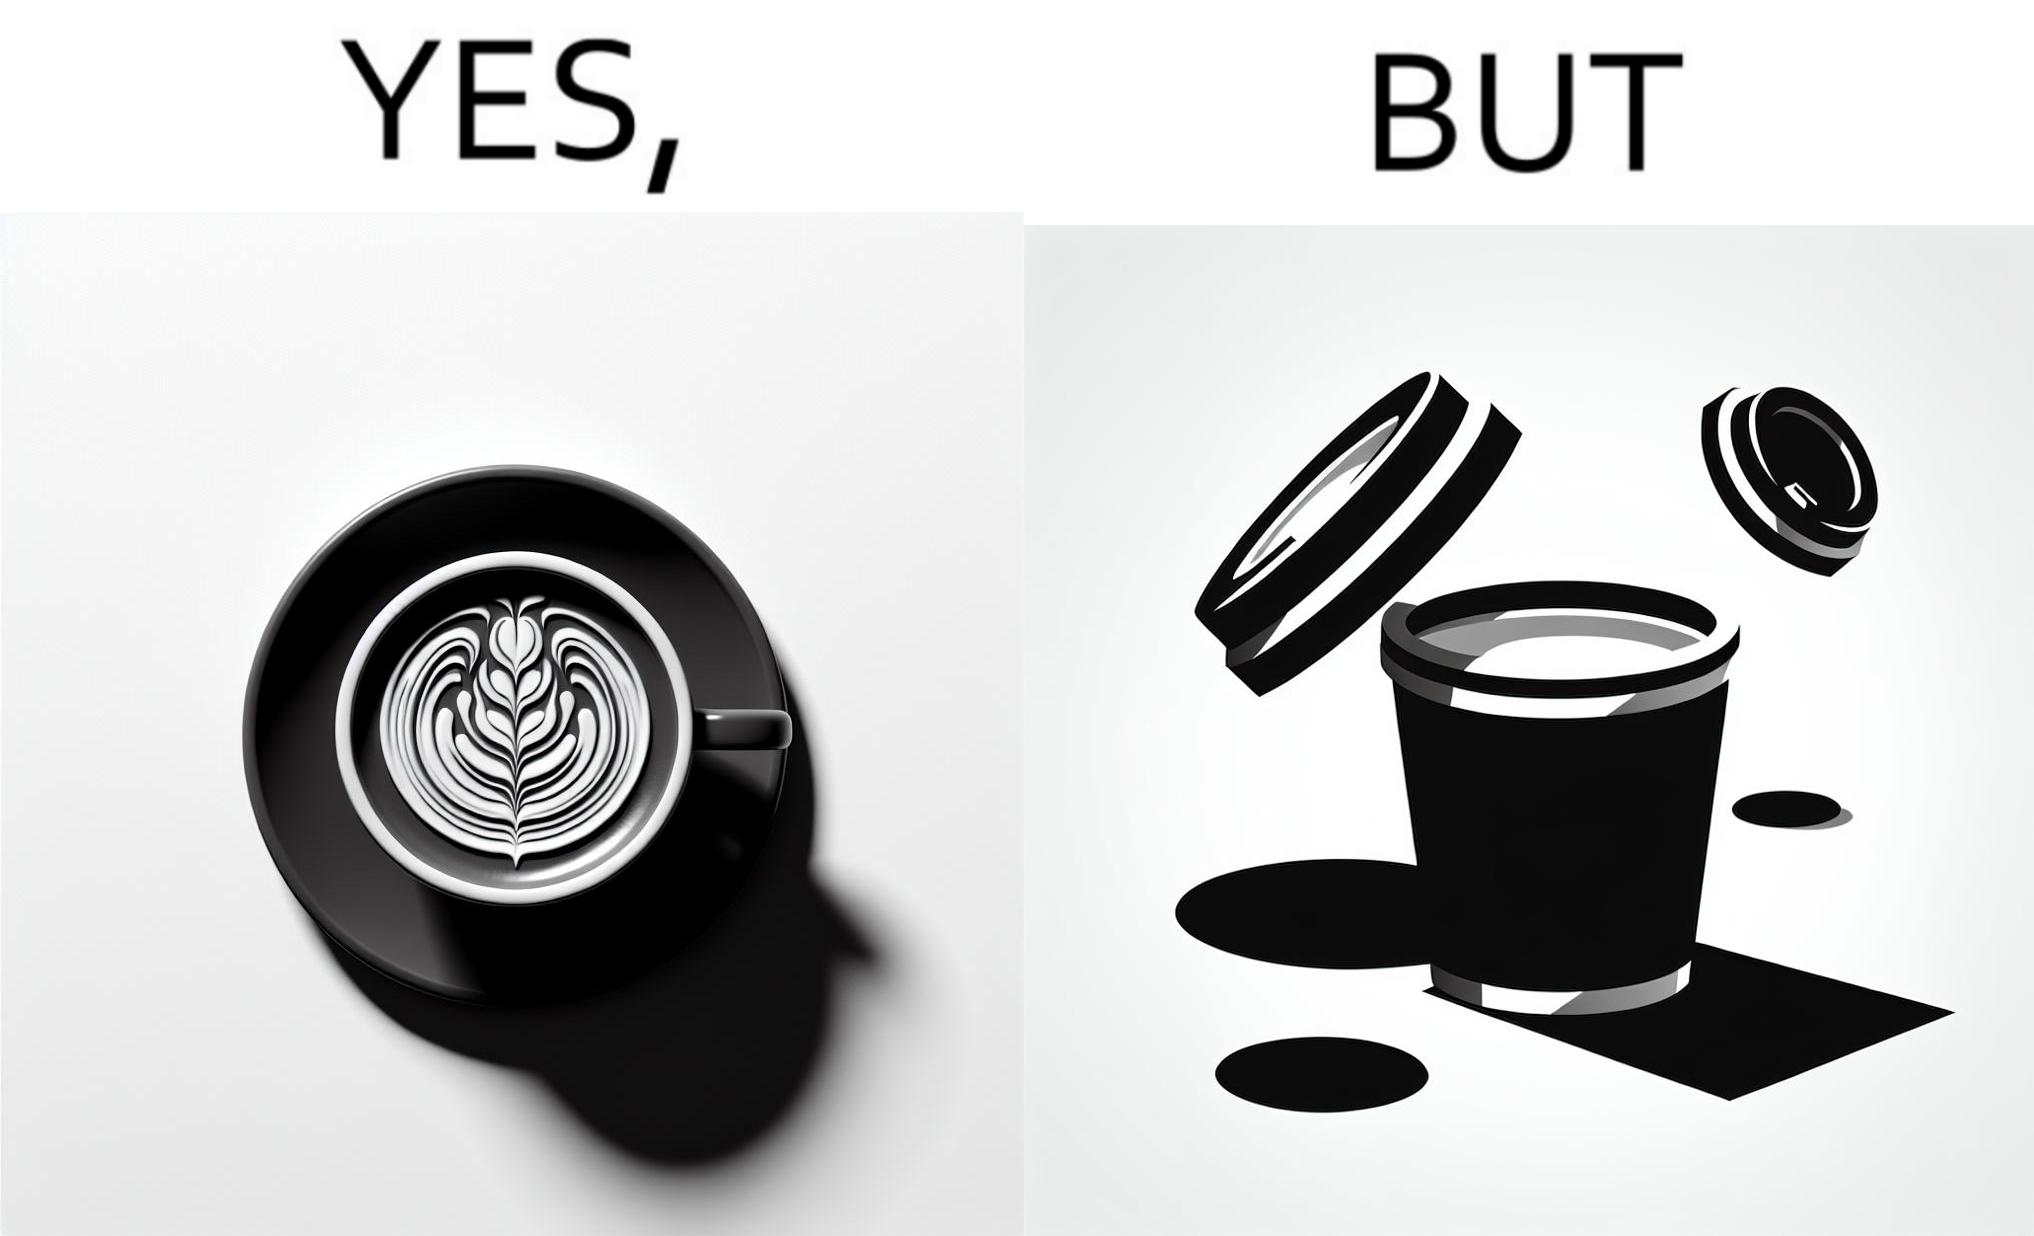Does this image contain satire or humor? Yes, this image is satirical. 